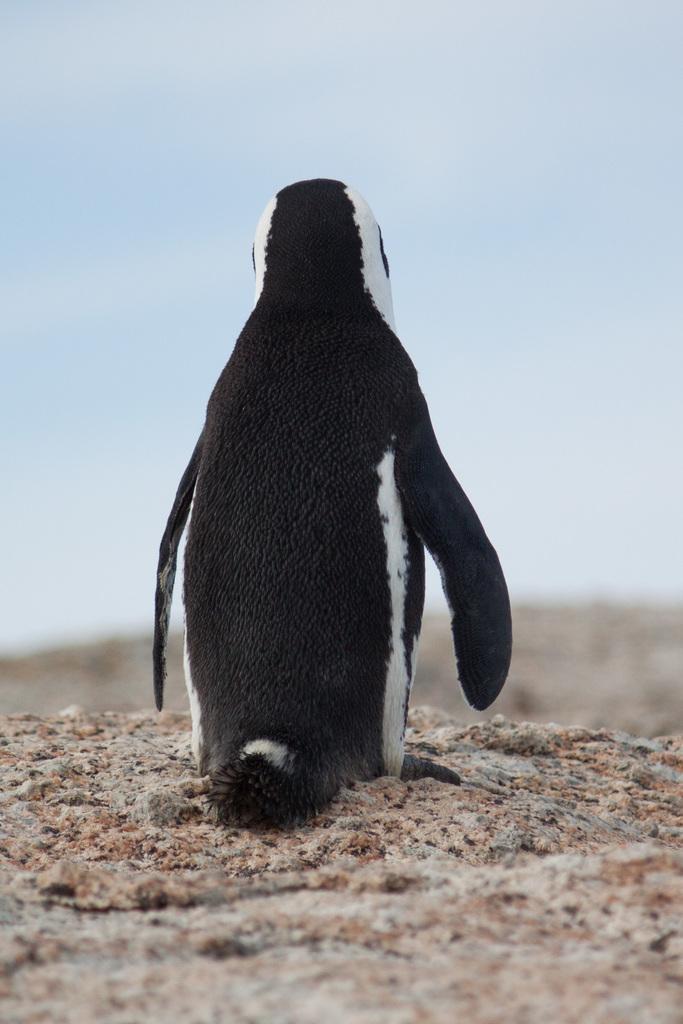Describe this image in one or two sentences. There is a penguin on the ground. There is a blur background and we can see sky. 